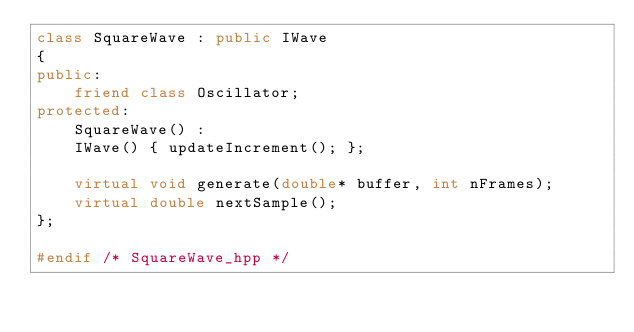<code> <loc_0><loc_0><loc_500><loc_500><_C++_>class SquareWave : public IWave
{
public:
    friend class Oscillator;
protected:
    SquareWave() :
    IWave() { updateIncrement(); };

    virtual void generate(double* buffer, int nFrames);
    virtual double nextSample();
};

#endif /* SquareWave_hpp */
</code> 